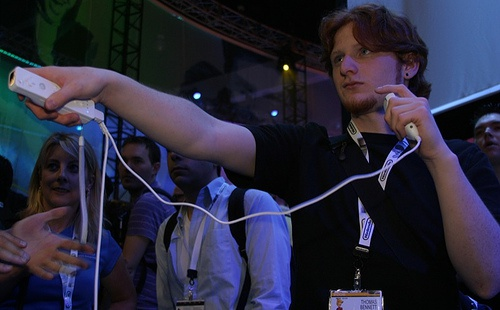Describe the objects in this image and their specific colors. I can see people in black, purple, and maroon tones, people in black, blue, purple, and navy tones, people in black, navy, and blue tones, people in black, navy, gray, and darkgray tones, and people in black, purple, and maroon tones in this image. 